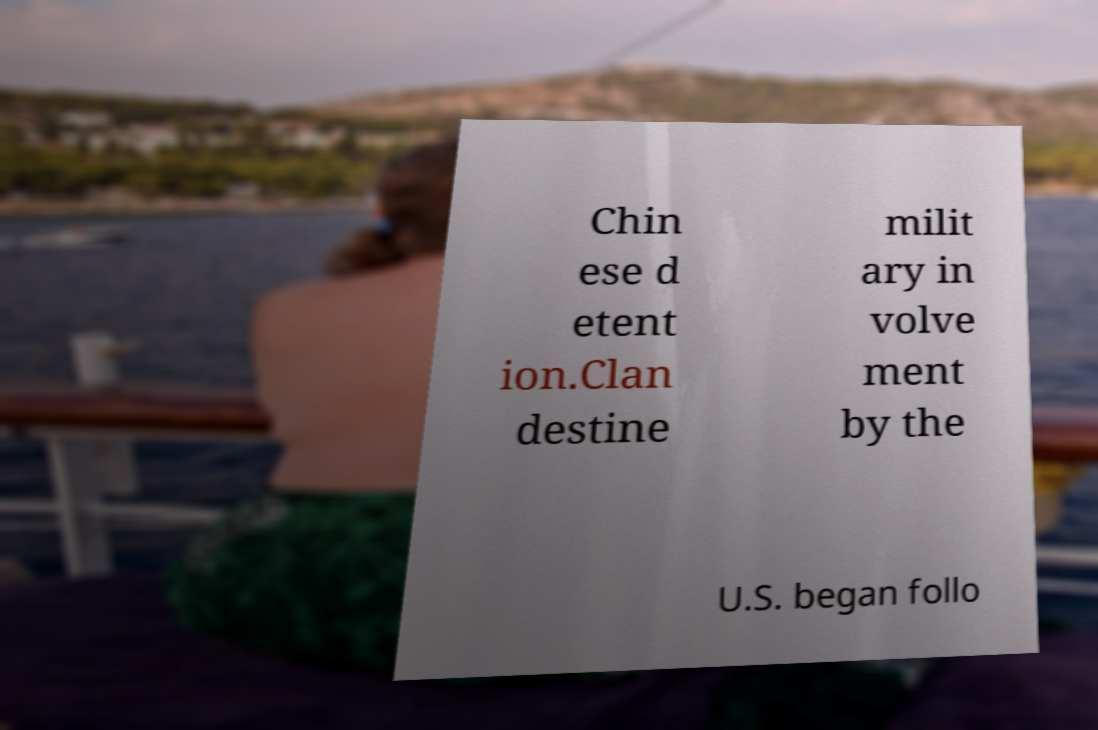Can you accurately transcribe the text from the provided image for me? Chin ese d etent ion.Clan destine milit ary in volve ment by the U.S. began follo 